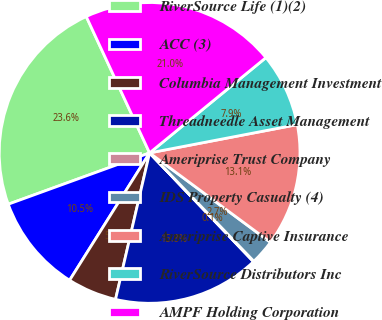Convert chart to OTSL. <chart><loc_0><loc_0><loc_500><loc_500><pie_chart><fcel>RiverSource Life (1)(2)<fcel>ACC (3)<fcel>Columbia Management Investment<fcel>Threadneedle Asset Management<fcel>Ameriprise Trust Company<fcel>IDS Property Casualty (4)<fcel>Ameriprise Captive Insurance<fcel>RiverSource Distributors Inc<fcel>AMPF Holding Corporation<nl><fcel>23.62%<fcel>10.53%<fcel>5.29%<fcel>15.77%<fcel>0.06%<fcel>2.67%<fcel>13.15%<fcel>7.91%<fcel>21.0%<nl></chart> 